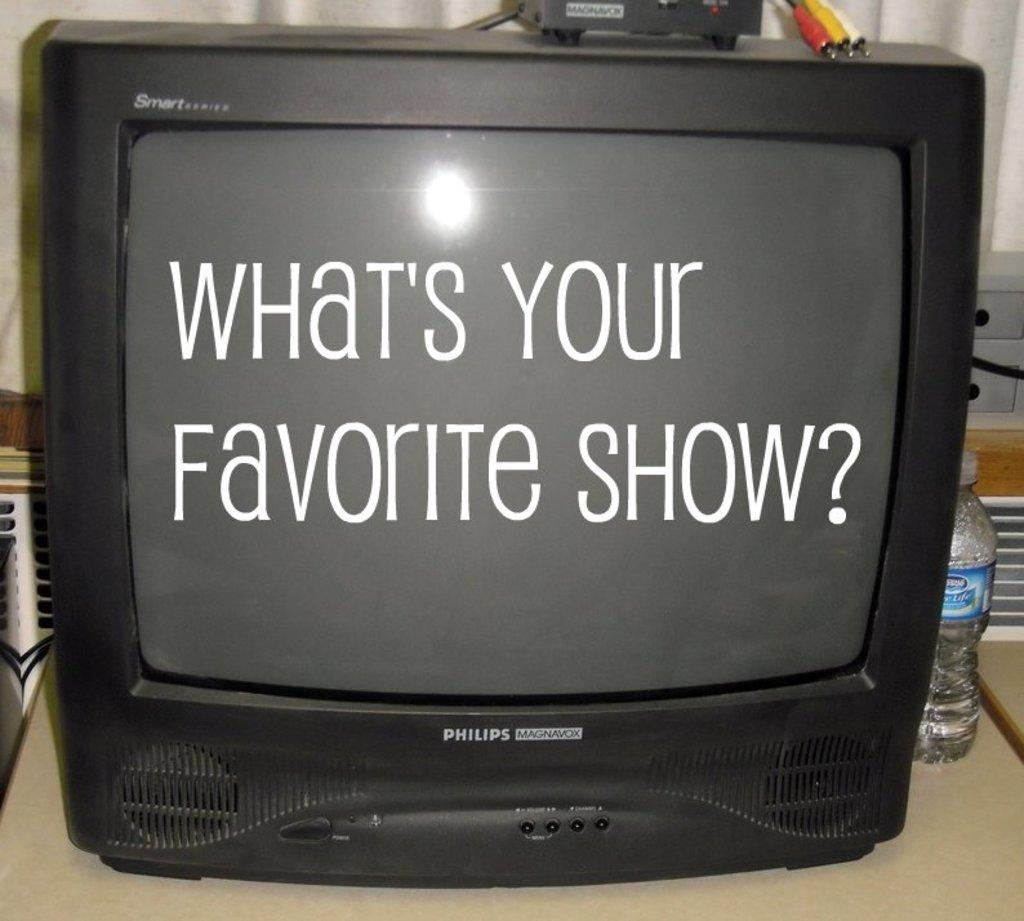<image>
Render a clear and concise summary of the photo. A TV with the text "What's your favorite show?" written on it. 